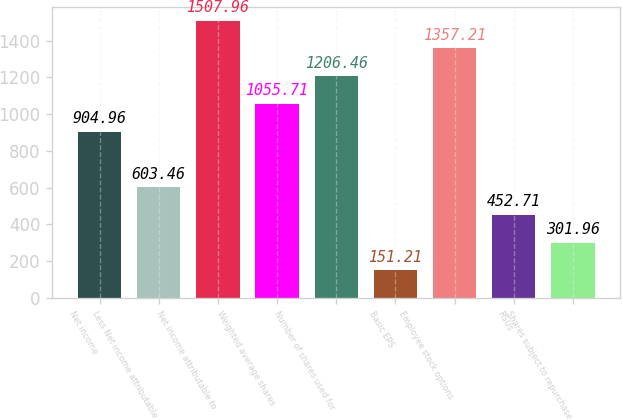Convert chart. <chart><loc_0><loc_0><loc_500><loc_500><bar_chart><fcel>Net income<fcel>Less Net income attributable<fcel>Net income attributable to<fcel>Weighted average shares<fcel>Number of shares used for<fcel>Basic EPS<fcel>Employee stock options<fcel>RSUs<fcel>Shares subject to repurchase<nl><fcel>904.96<fcel>603.46<fcel>1507.96<fcel>1055.71<fcel>1206.46<fcel>151.21<fcel>1357.21<fcel>452.71<fcel>301.96<nl></chart> 